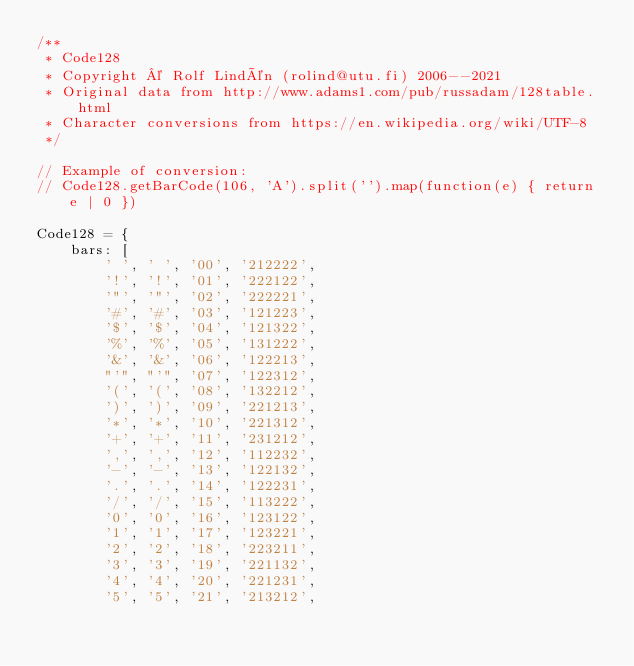Convert code to text. <code><loc_0><loc_0><loc_500><loc_500><_JavaScript_>/**
 * Code128
 * Copyright © Rolf Lindén (rolind@utu.fi) 2006--2021
 * Original data from http://www.adams1.com/pub/russadam/128table.html
 * Character conversions from https://en.wikipedia.org/wiki/UTF-8
 */

// Example of conversion:
// Code128.getBarCode(106, 'A').split('').map(function(e) { return e | 0 })

Code128 = {
	bars: [
		' ', ' ', '00', '212222',
		'!', '!', '01', '222122',
		'"', '"', '02', '222221',
		'#', '#', '03', '121223',
		'$', '$', '04', '121322',
		'%', '%', '05', '131222',
		'&', '&', '06', '122213',
		"'", "'", '07', '122312',
		'(', '(', '08', '132212',
		')', ')', '09', '221213',
		'*', '*', '10', '221312',
		'+', '+', '11', '231212',
		',', ',', '12', '112232',
		'-', '-', '13', '122132',
		'.', '.', '14', '122231',
		'/', '/', '15', '113222',
		'0', '0', '16', '123122',
		'1', '1', '17', '123221',
		'2', '2', '18', '223211',
		'3', '3', '19', '221132',
		'4', '4', '20', '221231',
		'5', '5', '21', '213212',</code> 